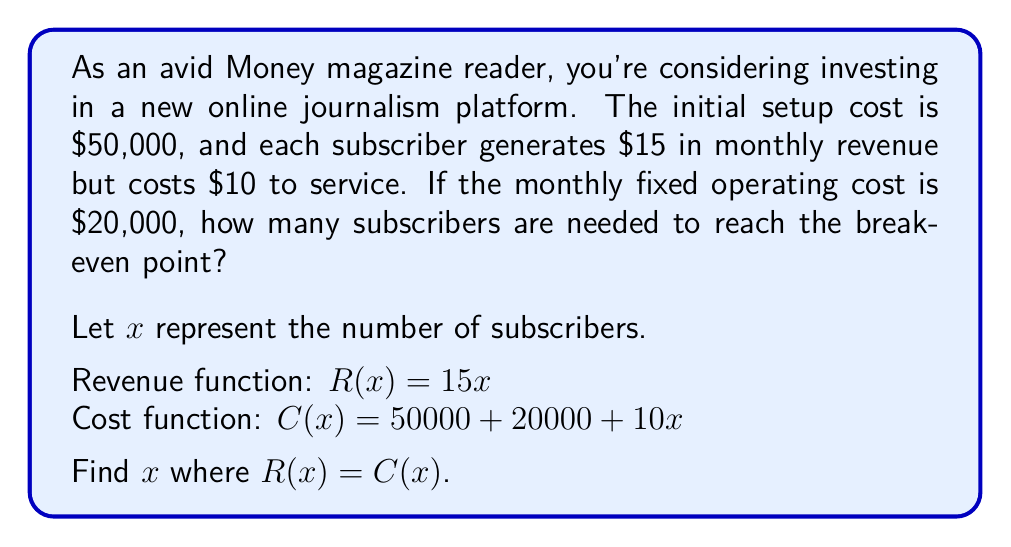Solve this math problem. To determine the break-even point, we need to find where the revenue equals the total cost:

1) Set up the equation:
   $R(x) = C(x)$
   $15x = 50000 + 20000 + 10x$

2) Simplify the right side:
   $15x = 70000 + 10x$

3) Subtract $10x$ from both sides:
   $5x = 70000$

4) Divide both sides by 5:
   $x = 14000$

5) Check:
   Revenue: $R(14000) = 15 * 14000 = 210000$
   Cost: $C(14000) = 50000 + 20000 + 10 * 14000 = 210000$

Therefore, the break-even point is 14,000 subscribers.
Answer: 14,000 subscribers 